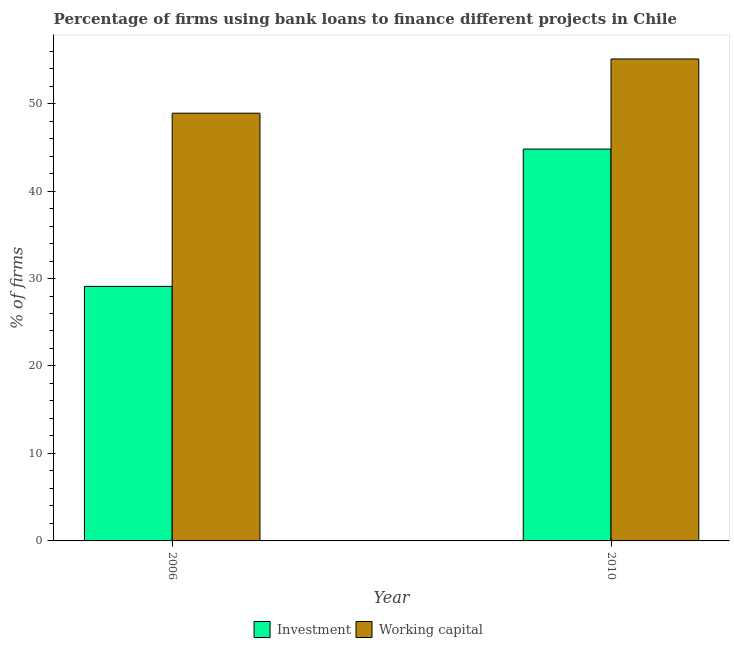How many different coloured bars are there?
Keep it short and to the point. 2. How many groups of bars are there?
Offer a very short reply. 2. How many bars are there on the 2nd tick from the right?
Your response must be concise. 2. What is the percentage of firms using banks to finance working capital in 2006?
Provide a short and direct response. 48.9. Across all years, what is the maximum percentage of firms using banks to finance working capital?
Provide a succinct answer. 55.1. Across all years, what is the minimum percentage of firms using banks to finance working capital?
Give a very brief answer. 48.9. In which year was the percentage of firms using banks to finance working capital maximum?
Offer a very short reply. 2010. In which year was the percentage of firms using banks to finance working capital minimum?
Provide a short and direct response. 2006. What is the total percentage of firms using banks to finance investment in the graph?
Ensure brevity in your answer.  73.9. What is the difference between the percentage of firms using banks to finance investment in 2006 and that in 2010?
Your answer should be compact. -15.7. What is the difference between the percentage of firms using banks to finance investment in 2010 and the percentage of firms using banks to finance working capital in 2006?
Make the answer very short. 15.7. What is the average percentage of firms using banks to finance investment per year?
Offer a terse response. 36.95. What is the ratio of the percentage of firms using banks to finance investment in 2006 to that in 2010?
Keep it short and to the point. 0.65. Is the percentage of firms using banks to finance working capital in 2006 less than that in 2010?
Ensure brevity in your answer.  Yes. What does the 2nd bar from the left in 2006 represents?
Your response must be concise. Working capital. What does the 2nd bar from the right in 2010 represents?
Provide a short and direct response. Investment. Are all the bars in the graph horizontal?
Ensure brevity in your answer.  No. How many years are there in the graph?
Ensure brevity in your answer.  2. What is the difference between two consecutive major ticks on the Y-axis?
Your answer should be compact. 10. Are the values on the major ticks of Y-axis written in scientific E-notation?
Give a very brief answer. No. Does the graph contain grids?
Make the answer very short. No. How are the legend labels stacked?
Offer a terse response. Horizontal. What is the title of the graph?
Keep it short and to the point. Percentage of firms using bank loans to finance different projects in Chile. Does "Travel Items" appear as one of the legend labels in the graph?
Give a very brief answer. No. What is the label or title of the Y-axis?
Provide a short and direct response. % of firms. What is the % of firms of Investment in 2006?
Provide a short and direct response. 29.1. What is the % of firms in Working capital in 2006?
Provide a succinct answer. 48.9. What is the % of firms of Investment in 2010?
Provide a succinct answer. 44.8. What is the % of firms in Working capital in 2010?
Make the answer very short. 55.1. Across all years, what is the maximum % of firms in Investment?
Ensure brevity in your answer.  44.8. Across all years, what is the maximum % of firms in Working capital?
Your answer should be compact. 55.1. Across all years, what is the minimum % of firms in Investment?
Ensure brevity in your answer.  29.1. Across all years, what is the minimum % of firms of Working capital?
Your response must be concise. 48.9. What is the total % of firms in Investment in the graph?
Provide a succinct answer. 73.9. What is the total % of firms in Working capital in the graph?
Offer a terse response. 104. What is the difference between the % of firms of Investment in 2006 and that in 2010?
Ensure brevity in your answer.  -15.7. What is the difference between the % of firms of Investment in 2006 and the % of firms of Working capital in 2010?
Give a very brief answer. -26. What is the average % of firms of Investment per year?
Offer a very short reply. 36.95. In the year 2006, what is the difference between the % of firms in Investment and % of firms in Working capital?
Keep it short and to the point. -19.8. What is the ratio of the % of firms of Investment in 2006 to that in 2010?
Give a very brief answer. 0.65. What is the ratio of the % of firms in Working capital in 2006 to that in 2010?
Offer a terse response. 0.89. What is the difference between the highest and the lowest % of firms in Investment?
Keep it short and to the point. 15.7. 